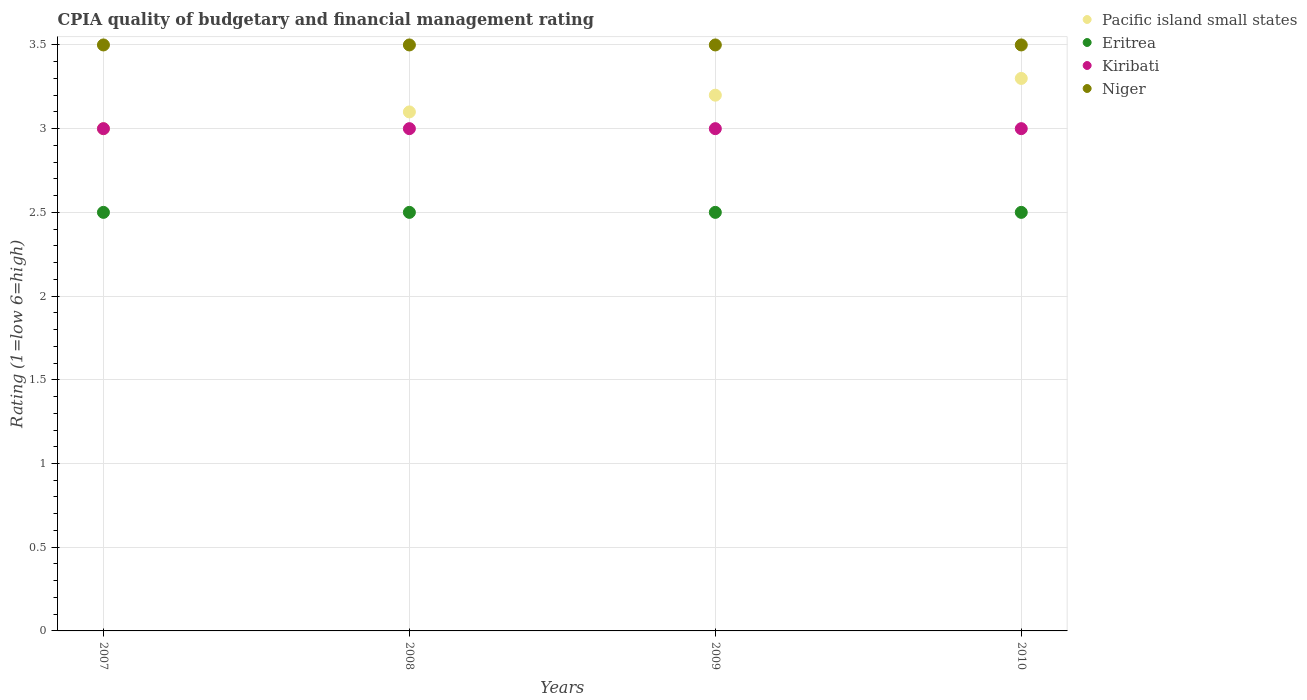How many different coloured dotlines are there?
Your answer should be very brief. 4. Across all years, what is the maximum CPIA rating in Kiribati?
Keep it short and to the point. 3. Across all years, what is the minimum CPIA rating in Pacific island small states?
Provide a succinct answer. 3. What is the total CPIA rating in Pacific island small states in the graph?
Give a very brief answer. 12.6. What is the difference between the CPIA rating in Pacific island small states in 2007 and that in 2009?
Ensure brevity in your answer.  -0.2. In the year 2008, what is the difference between the CPIA rating in Niger and CPIA rating in Kiribati?
Your answer should be very brief. 0.5. What is the difference between the highest and the second highest CPIA rating in Pacific island small states?
Provide a succinct answer. 0.1. What is the difference between the highest and the lowest CPIA rating in Kiribati?
Offer a terse response. 0. In how many years, is the CPIA rating in Pacific island small states greater than the average CPIA rating in Pacific island small states taken over all years?
Make the answer very short. 2. Is the sum of the CPIA rating in Kiribati in 2007 and 2009 greater than the maximum CPIA rating in Eritrea across all years?
Give a very brief answer. Yes. Is it the case that in every year, the sum of the CPIA rating in Niger and CPIA rating in Eritrea  is greater than the CPIA rating in Pacific island small states?
Keep it short and to the point. Yes. Does the CPIA rating in Kiribati monotonically increase over the years?
Your response must be concise. No. Is the CPIA rating in Kiribati strictly greater than the CPIA rating in Pacific island small states over the years?
Keep it short and to the point. No. Does the graph contain any zero values?
Make the answer very short. No. Does the graph contain grids?
Your answer should be very brief. Yes. Where does the legend appear in the graph?
Make the answer very short. Top right. What is the title of the graph?
Offer a terse response. CPIA quality of budgetary and financial management rating. What is the Rating (1=low 6=high) of Pacific island small states in 2007?
Provide a short and direct response. 3. What is the Rating (1=low 6=high) of Eritrea in 2007?
Provide a short and direct response. 2.5. What is the Rating (1=low 6=high) of Kiribati in 2007?
Your response must be concise. 3. What is the Rating (1=low 6=high) in Niger in 2007?
Provide a short and direct response. 3.5. What is the Rating (1=low 6=high) of Pacific island small states in 2008?
Your answer should be very brief. 3.1. What is the Rating (1=low 6=high) in Pacific island small states in 2009?
Offer a very short reply. 3.2. What is the Rating (1=low 6=high) in Pacific island small states in 2010?
Give a very brief answer. 3.3. What is the Rating (1=low 6=high) of Kiribati in 2010?
Keep it short and to the point. 3. What is the Rating (1=low 6=high) of Niger in 2010?
Your response must be concise. 3.5. Across all years, what is the maximum Rating (1=low 6=high) in Pacific island small states?
Your response must be concise. 3.3. Across all years, what is the maximum Rating (1=low 6=high) in Eritrea?
Offer a terse response. 2.5. Across all years, what is the minimum Rating (1=low 6=high) of Pacific island small states?
Provide a succinct answer. 3. Across all years, what is the minimum Rating (1=low 6=high) in Niger?
Ensure brevity in your answer.  3.5. What is the total Rating (1=low 6=high) in Eritrea in the graph?
Your answer should be compact. 10. What is the difference between the Rating (1=low 6=high) of Pacific island small states in 2007 and that in 2008?
Offer a terse response. -0.1. What is the difference between the Rating (1=low 6=high) in Eritrea in 2007 and that in 2008?
Provide a short and direct response. 0. What is the difference between the Rating (1=low 6=high) of Kiribati in 2007 and that in 2008?
Ensure brevity in your answer.  0. What is the difference between the Rating (1=low 6=high) in Pacific island small states in 2007 and that in 2009?
Keep it short and to the point. -0.2. What is the difference between the Rating (1=low 6=high) of Kiribati in 2007 and that in 2009?
Your answer should be very brief. 0. What is the difference between the Rating (1=low 6=high) in Niger in 2007 and that in 2009?
Ensure brevity in your answer.  0. What is the difference between the Rating (1=low 6=high) in Pacific island small states in 2007 and that in 2010?
Provide a succinct answer. -0.3. What is the difference between the Rating (1=low 6=high) in Eritrea in 2007 and that in 2010?
Your answer should be very brief. 0. What is the difference between the Rating (1=low 6=high) of Pacific island small states in 2008 and that in 2009?
Provide a short and direct response. -0.1. What is the difference between the Rating (1=low 6=high) of Kiribati in 2008 and that in 2009?
Your answer should be compact. 0. What is the difference between the Rating (1=low 6=high) in Niger in 2008 and that in 2009?
Give a very brief answer. 0. What is the difference between the Rating (1=low 6=high) in Niger in 2008 and that in 2010?
Your answer should be compact. 0. What is the difference between the Rating (1=low 6=high) of Kiribati in 2009 and that in 2010?
Make the answer very short. 0. What is the difference between the Rating (1=low 6=high) of Niger in 2009 and that in 2010?
Your answer should be very brief. 0. What is the difference between the Rating (1=low 6=high) of Pacific island small states in 2007 and the Rating (1=low 6=high) of Eritrea in 2008?
Make the answer very short. 0.5. What is the difference between the Rating (1=low 6=high) of Pacific island small states in 2007 and the Rating (1=low 6=high) of Kiribati in 2008?
Your answer should be very brief. 0. What is the difference between the Rating (1=low 6=high) in Pacific island small states in 2007 and the Rating (1=low 6=high) in Niger in 2008?
Give a very brief answer. -0.5. What is the difference between the Rating (1=low 6=high) in Eritrea in 2007 and the Rating (1=low 6=high) in Kiribati in 2008?
Make the answer very short. -0.5. What is the difference between the Rating (1=low 6=high) of Eritrea in 2007 and the Rating (1=low 6=high) of Niger in 2008?
Provide a succinct answer. -1. What is the difference between the Rating (1=low 6=high) in Kiribati in 2007 and the Rating (1=low 6=high) in Niger in 2008?
Provide a short and direct response. -0.5. What is the difference between the Rating (1=low 6=high) of Pacific island small states in 2007 and the Rating (1=low 6=high) of Niger in 2009?
Offer a terse response. -0.5. What is the difference between the Rating (1=low 6=high) of Kiribati in 2007 and the Rating (1=low 6=high) of Niger in 2009?
Make the answer very short. -0.5. What is the difference between the Rating (1=low 6=high) of Pacific island small states in 2007 and the Rating (1=low 6=high) of Kiribati in 2010?
Your answer should be very brief. 0. What is the difference between the Rating (1=low 6=high) in Pacific island small states in 2007 and the Rating (1=low 6=high) in Niger in 2010?
Your answer should be very brief. -0.5. What is the difference between the Rating (1=low 6=high) in Eritrea in 2007 and the Rating (1=low 6=high) in Kiribati in 2010?
Your answer should be very brief. -0.5. What is the difference between the Rating (1=low 6=high) in Eritrea in 2007 and the Rating (1=low 6=high) in Niger in 2010?
Make the answer very short. -1. What is the difference between the Rating (1=low 6=high) in Pacific island small states in 2008 and the Rating (1=low 6=high) in Eritrea in 2009?
Your answer should be compact. 0.6. What is the difference between the Rating (1=low 6=high) in Pacific island small states in 2008 and the Rating (1=low 6=high) in Niger in 2009?
Offer a very short reply. -0.4. What is the difference between the Rating (1=low 6=high) of Eritrea in 2008 and the Rating (1=low 6=high) of Kiribati in 2009?
Ensure brevity in your answer.  -0.5. What is the difference between the Rating (1=low 6=high) of Eritrea in 2008 and the Rating (1=low 6=high) of Niger in 2009?
Offer a terse response. -1. What is the difference between the Rating (1=low 6=high) in Kiribati in 2008 and the Rating (1=low 6=high) in Niger in 2009?
Your response must be concise. -0.5. What is the difference between the Rating (1=low 6=high) in Pacific island small states in 2008 and the Rating (1=low 6=high) in Niger in 2010?
Your answer should be compact. -0.4. What is the difference between the Rating (1=low 6=high) of Eritrea in 2008 and the Rating (1=low 6=high) of Kiribati in 2010?
Keep it short and to the point. -0.5. What is the difference between the Rating (1=low 6=high) in Eritrea in 2008 and the Rating (1=low 6=high) in Niger in 2010?
Your response must be concise. -1. What is the difference between the Rating (1=low 6=high) in Pacific island small states in 2009 and the Rating (1=low 6=high) in Kiribati in 2010?
Give a very brief answer. 0.2. What is the difference between the Rating (1=low 6=high) of Pacific island small states in 2009 and the Rating (1=low 6=high) of Niger in 2010?
Ensure brevity in your answer.  -0.3. What is the difference between the Rating (1=low 6=high) in Eritrea in 2009 and the Rating (1=low 6=high) in Kiribati in 2010?
Ensure brevity in your answer.  -0.5. What is the difference between the Rating (1=low 6=high) of Eritrea in 2009 and the Rating (1=low 6=high) of Niger in 2010?
Your response must be concise. -1. What is the average Rating (1=low 6=high) of Pacific island small states per year?
Keep it short and to the point. 3.15. What is the average Rating (1=low 6=high) of Kiribati per year?
Keep it short and to the point. 3. In the year 2007, what is the difference between the Rating (1=low 6=high) of Pacific island small states and Rating (1=low 6=high) of Eritrea?
Your answer should be compact. 0.5. In the year 2007, what is the difference between the Rating (1=low 6=high) of Eritrea and Rating (1=low 6=high) of Kiribati?
Give a very brief answer. -0.5. In the year 2007, what is the difference between the Rating (1=low 6=high) in Eritrea and Rating (1=low 6=high) in Niger?
Your answer should be compact. -1. In the year 2008, what is the difference between the Rating (1=low 6=high) in Pacific island small states and Rating (1=low 6=high) in Eritrea?
Give a very brief answer. 0.6. In the year 2008, what is the difference between the Rating (1=low 6=high) of Pacific island small states and Rating (1=low 6=high) of Kiribati?
Your response must be concise. 0.1. In the year 2008, what is the difference between the Rating (1=low 6=high) of Eritrea and Rating (1=low 6=high) of Kiribati?
Keep it short and to the point. -0.5. In the year 2008, what is the difference between the Rating (1=low 6=high) in Kiribati and Rating (1=low 6=high) in Niger?
Offer a very short reply. -0.5. In the year 2009, what is the difference between the Rating (1=low 6=high) of Pacific island small states and Rating (1=low 6=high) of Kiribati?
Provide a short and direct response. 0.2. In the year 2009, what is the difference between the Rating (1=low 6=high) of Pacific island small states and Rating (1=low 6=high) of Niger?
Make the answer very short. -0.3. In the year 2010, what is the difference between the Rating (1=low 6=high) in Pacific island small states and Rating (1=low 6=high) in Niger?
Your response must be concise. -0.2. In the year 2010, what is the difference between the Rating (1=low 6=high) in Eritrea and Rating (1=low 6=high) in Kiribati?
Offer a very short reply. -0.5. In the year 2010, what is the difference between the Rating (1=low 6=high) of Kiribati and Rating (1=low 6=high) of Niger?
Offer a terse response. -0.5. What is the ratio of the Rating (1=low 6=high) in Pacific island small states in 2007 to that in 2009?
Your answer should be very brief. 0.94. What is the ratio of the Rating (1=low 6=high) in Eritrea in 2007 to that in 2009?
Offer a terse response. 1. What is the ratio of the Rating (1=low 6=high) of Kiribati in 2007 to that in 2009?
Provide a succinct answer. 1. What is the ratio of the Rating (1=low 6=high) of Niger in 2007 to that in 2009?
Your answer should be compact. 1. What is the ratio of the Rating (1=low 6=high) of Pacific island small states in 2007 to that in 2010?
Give a very brief answer. 0.91. What is the ratio of the Rating (1=low 6=high) in Eritrea in 2007 to that in 2010?
Make the answer very short. 1. What is the ratio of the Rating (1=low 6=high) in Kiribati in 2007 to that in 2010?
Ensure brevity in your answer.  1. What is the ratio of the Rating (1=low 6=high) in Pacific island small states in 2008 to that in 2009?
Your answer should be very brief. 0.97. What is the ratio of the Rating (1=low 6=high) of Pacific island small states in 2008 to that in 2010?
Make the answer very short. 0.94. What is the ratio of the Rating (1=low 6=high) of Eritrea in 2008 to that in 2010?
Offer a terse response. 1. What is the ratio of the Rating (1=low 6=high) in Kiribati in 2008 to that in 2010?
Your answer should be compact. 1. What is the ratio of the Rating (1=low 6=high) in Niger in 2008 to that in 2010?
Provide a short and direct response. 1. What is the ratio of the Rating (1=low 6=high) of Pacific island small states in 2009 to that in 2010?
Provide a short and direct response. 0.97. What is the ratio of the Rating (1=low 6=high) in Kiribati in 2009 to that in 2010?
Provide a succinct answer. 1. What is the ratio of the Rating (1=low 6=high) in Niger in 2009 to that in 2010?
Your response must be concise. 1. What is the difference between the highest and the second highest Rating (1=low 6=high) in Eritrea?
Give a very brief answer. 0. What is the difference between the highest and the second highest Rating (1=low 6=high) in Kiribati?
Your answer should be compact. 0. What is the difference between the highest and the lowest Rating (1=low 6=high) in Pacific island small states?
Your response must be concise. 0.3. What is the difference between the highest and the lowest Rating (1=low 6=high) in Eritrea?
Give a very brief answer. 0. What is the difference between the highest and the lowest Rating (1=low 6=high) in Niger?
Provide a short and direct response. 0. 